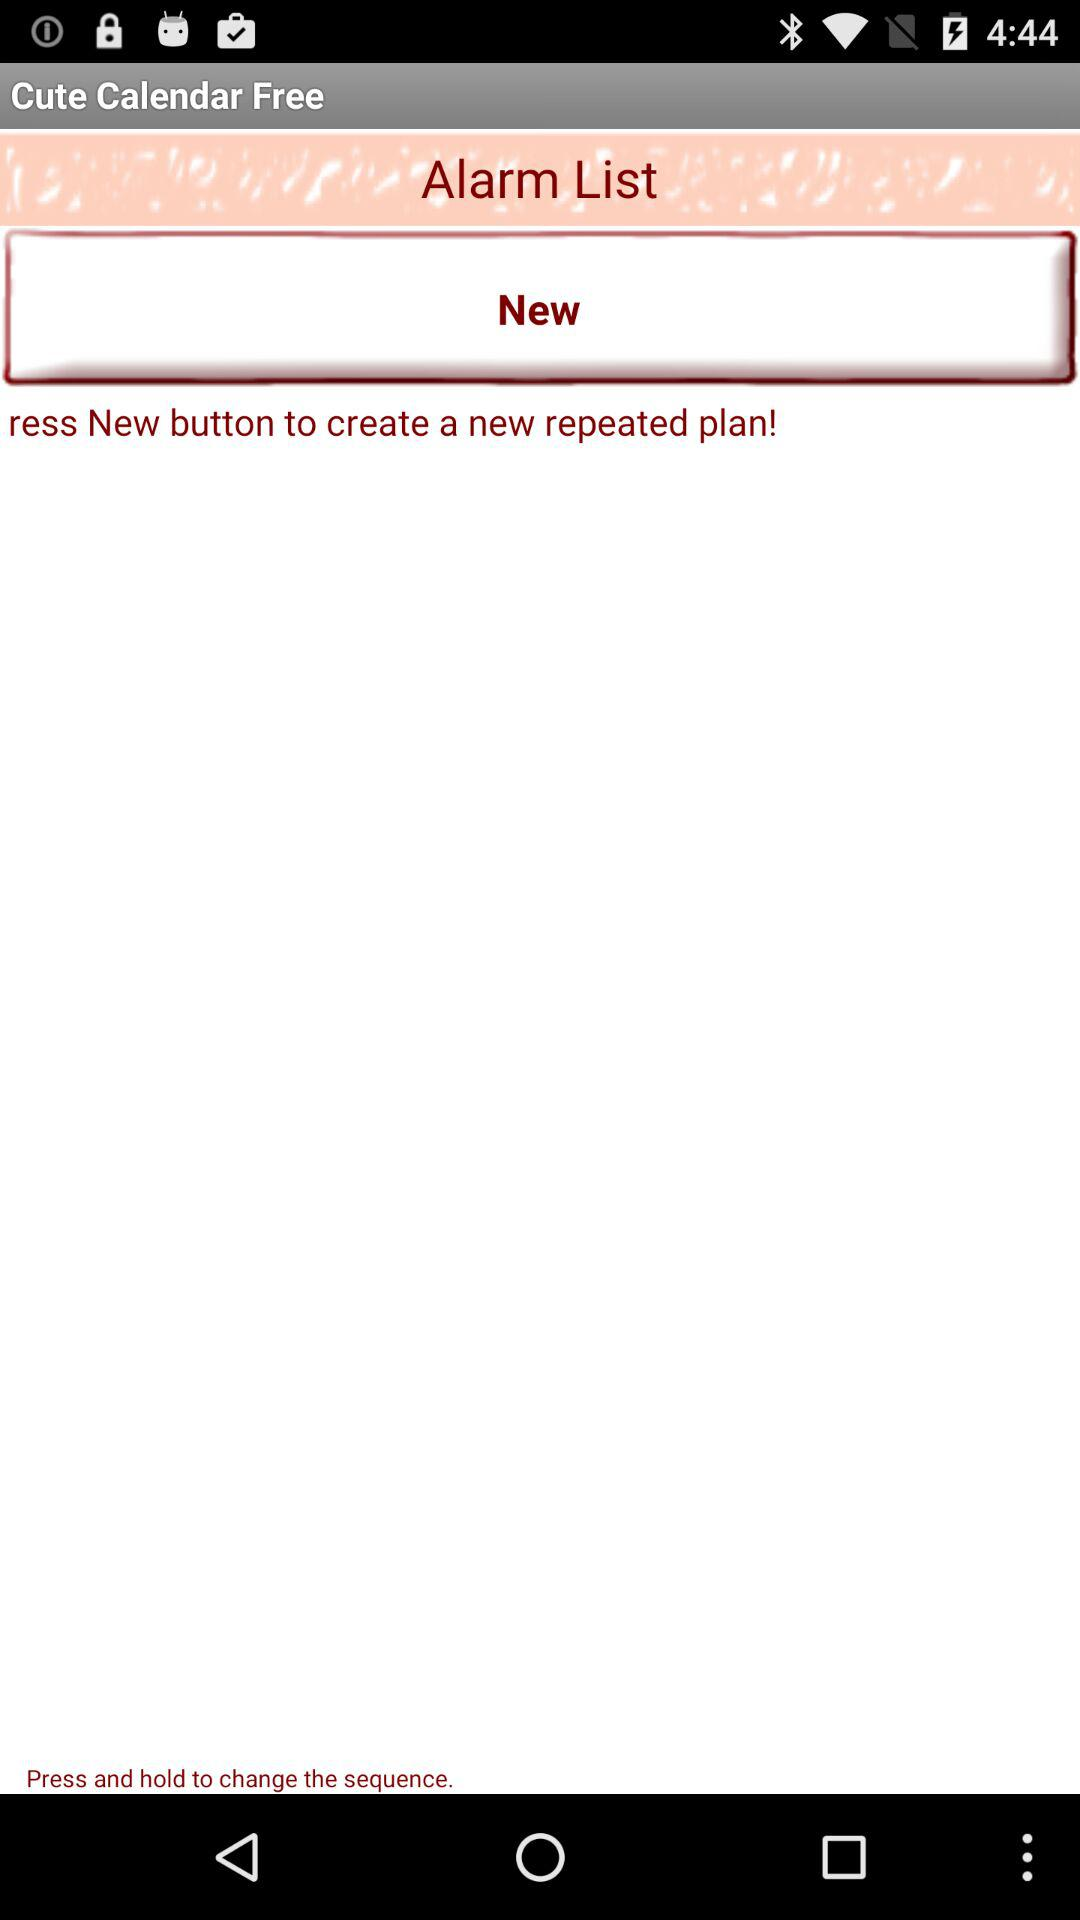What is the name of the application? The application name is "Cute Calendar". 